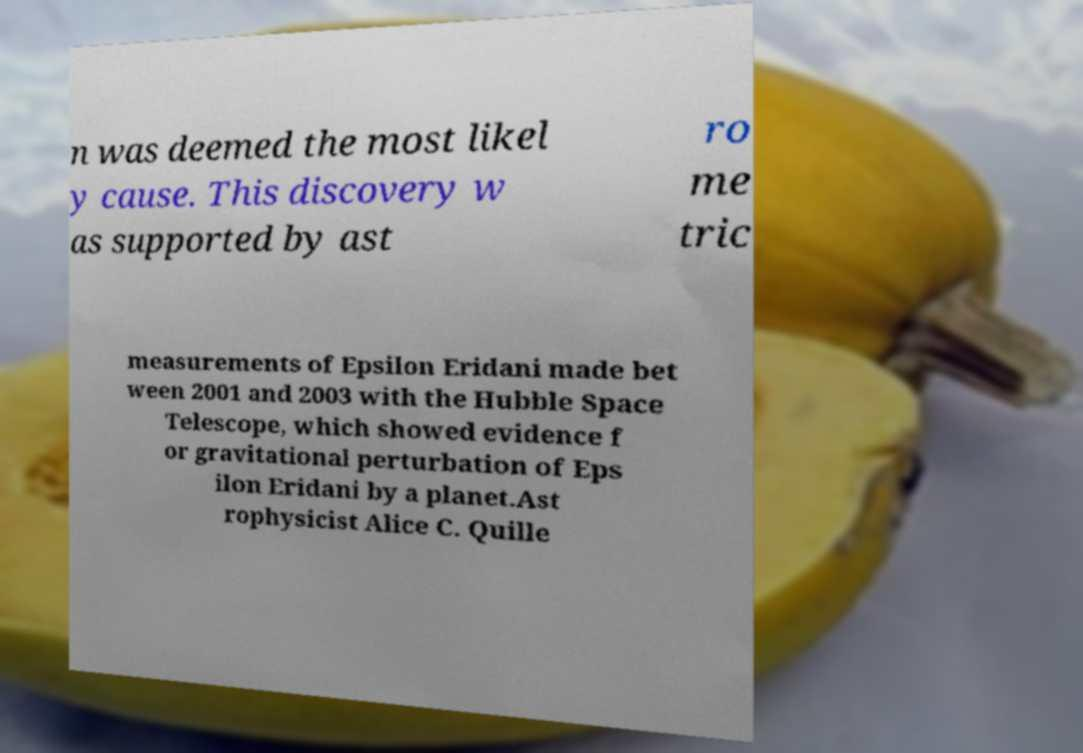Could you assist in decoding the text presented in this image and type it out clearly? n was deemed the most likel y cause. This discovery w as supported by ast ro me tric measurements of Epsilon Eridani made bet ween 2001 and 2003 with the Hubble Space Telescope, which showed evidence f or gravitational perturbation of Eps ilon Eridani by a planet.Ast rophysicist Alice C. Quille 